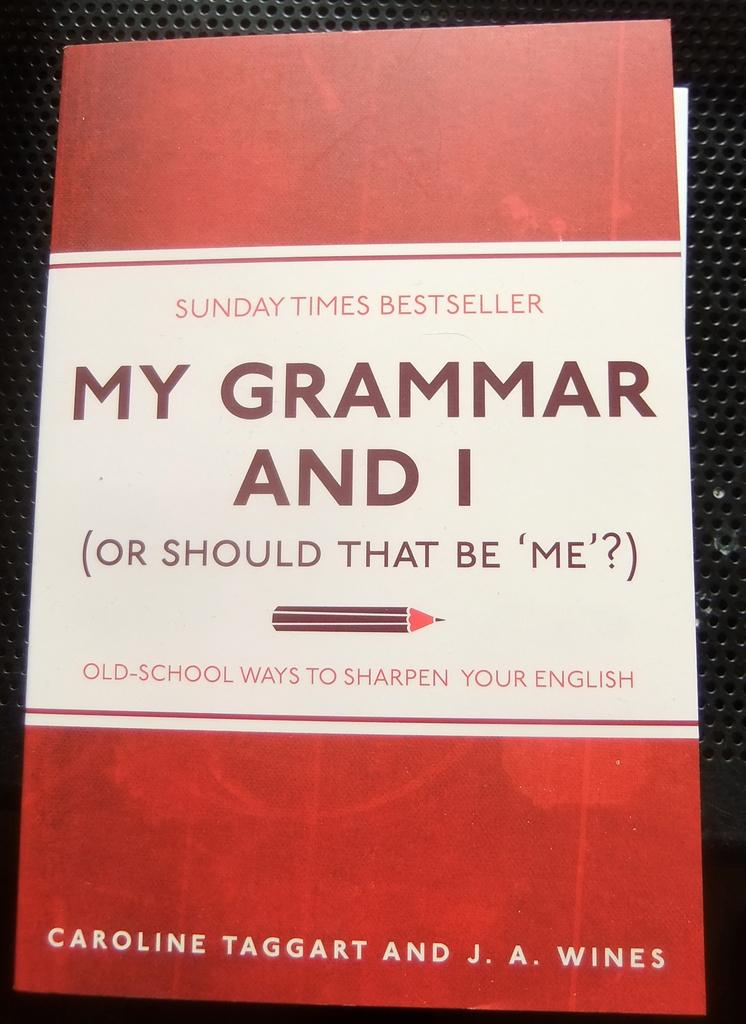<image>
Summarize the visual content of the image. A book cover of a book titled My Grammar and I is red and white. 